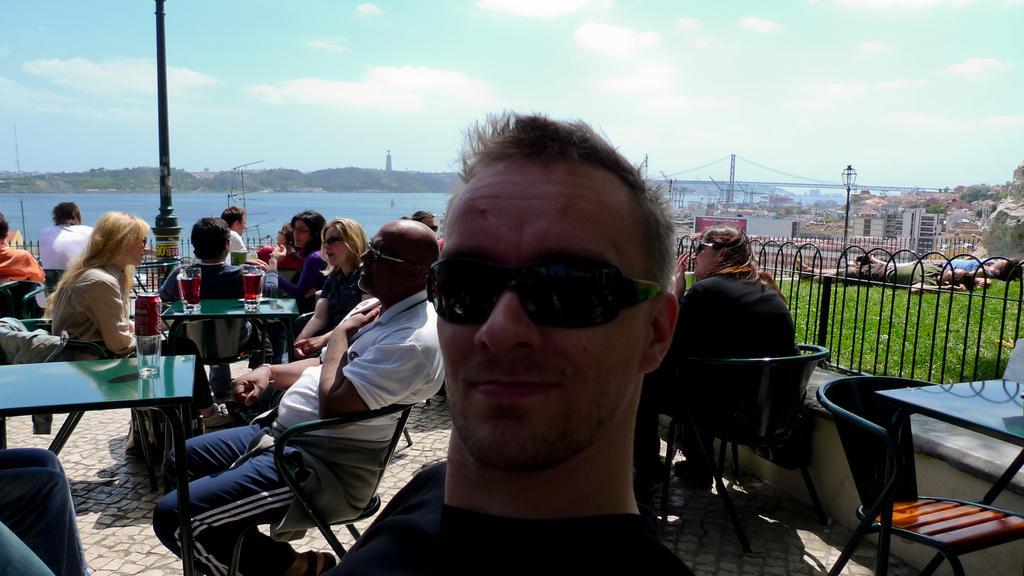Please provide a concise description of this image. In this image I see a man in front and he is wearing shades. In the background I see lot of people who are sitting on the chairs and there is a table in front and there are glasses on it and I can also see there are few poles, water, sky and 2 persons lying on the grass. 